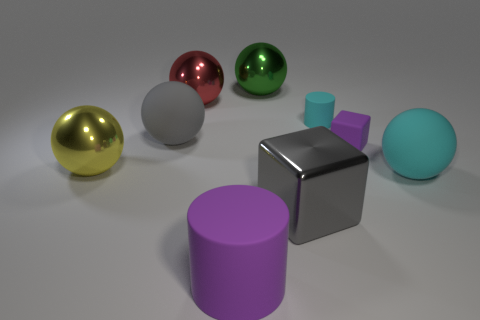What size is the sphere that is the same color as the small cylinder?
Your answer should be compact. Large. Does the small matte object that is to the right of the tiny cyan cylinder have the same color as the large shiny object behind the large red metal sphere?
Your answer should be very brief. No. What number of objects are either big yellow metallic objects or small blue spheres?
Offer a very short reply. 1. How many other objects are the same shape as the small purple object?
Your answer should be compact. 1. Does the cylinder in front of the purple rubber cube have the same material as the cyan thing that is behind the cyan rubber ball?
Offer a terse response. Yes. What is the shape of the object that is both in front of the purple cube and to the right of the big gray metal block?
Provide a succinct answer. Sphere. Is there any other thing that is made of the same material as the purple cylinder?
Make the answer very short. Yes. There is a big thing that is both behind the gray metal object and on the right side of the large green shiny thing; what is it made of?
Offer a very short reply. Rubber. What shape is the yellow object that is the same material as the green object?
Ensure brevity in your answer.  Sphere. Are there any other things that have the same color as the big matte cylinder?
Offer a terse response. Yes. 